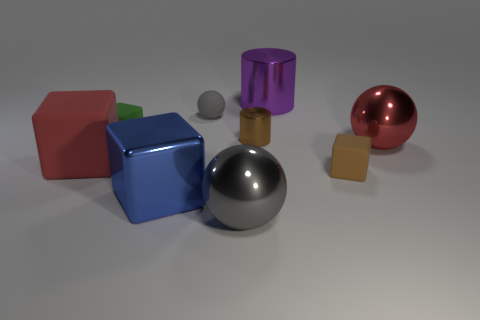Do the big sphere that is left of the brown shiny cylinder and the big blue object have the same material?
Give a very brief answer. Yes. What number of brown matte blocks are the same size as the green rubber thing?
Your answer should be very brief. 1. Are there more brown metal things to the right of the purple metal cylinder than tiny green rubber cubes behind the tiny sphere?
Offer a terse response. No. Are there any gray things of the same shape as the tiny green rubber thing?
Offer a terse response. No. There is a gray ball behind the red object that is on the right side of the brown matte thing; how big is it?
Your response must be concise. Small. There is a tiny gray object behind the large red object that is to the right of the gray ball to the right of the tiny gray sphere; what shape is it?
Provide a succinct answer. Sphere. The red thing that is made of the same material as the green object is what size?
Your answer should be very brief. Large. Are there more big gray metallic spheres than small red matte cylinders?
Keep it short and to the point. Yes. There is a red block that is the same size as the gray shiny thing; what is its material?
Offer a very short reply. Rubber. There is a metallic cylinder behind the green matte cube; is its size the same as the matte sphere?
Make the answer very short. No. 